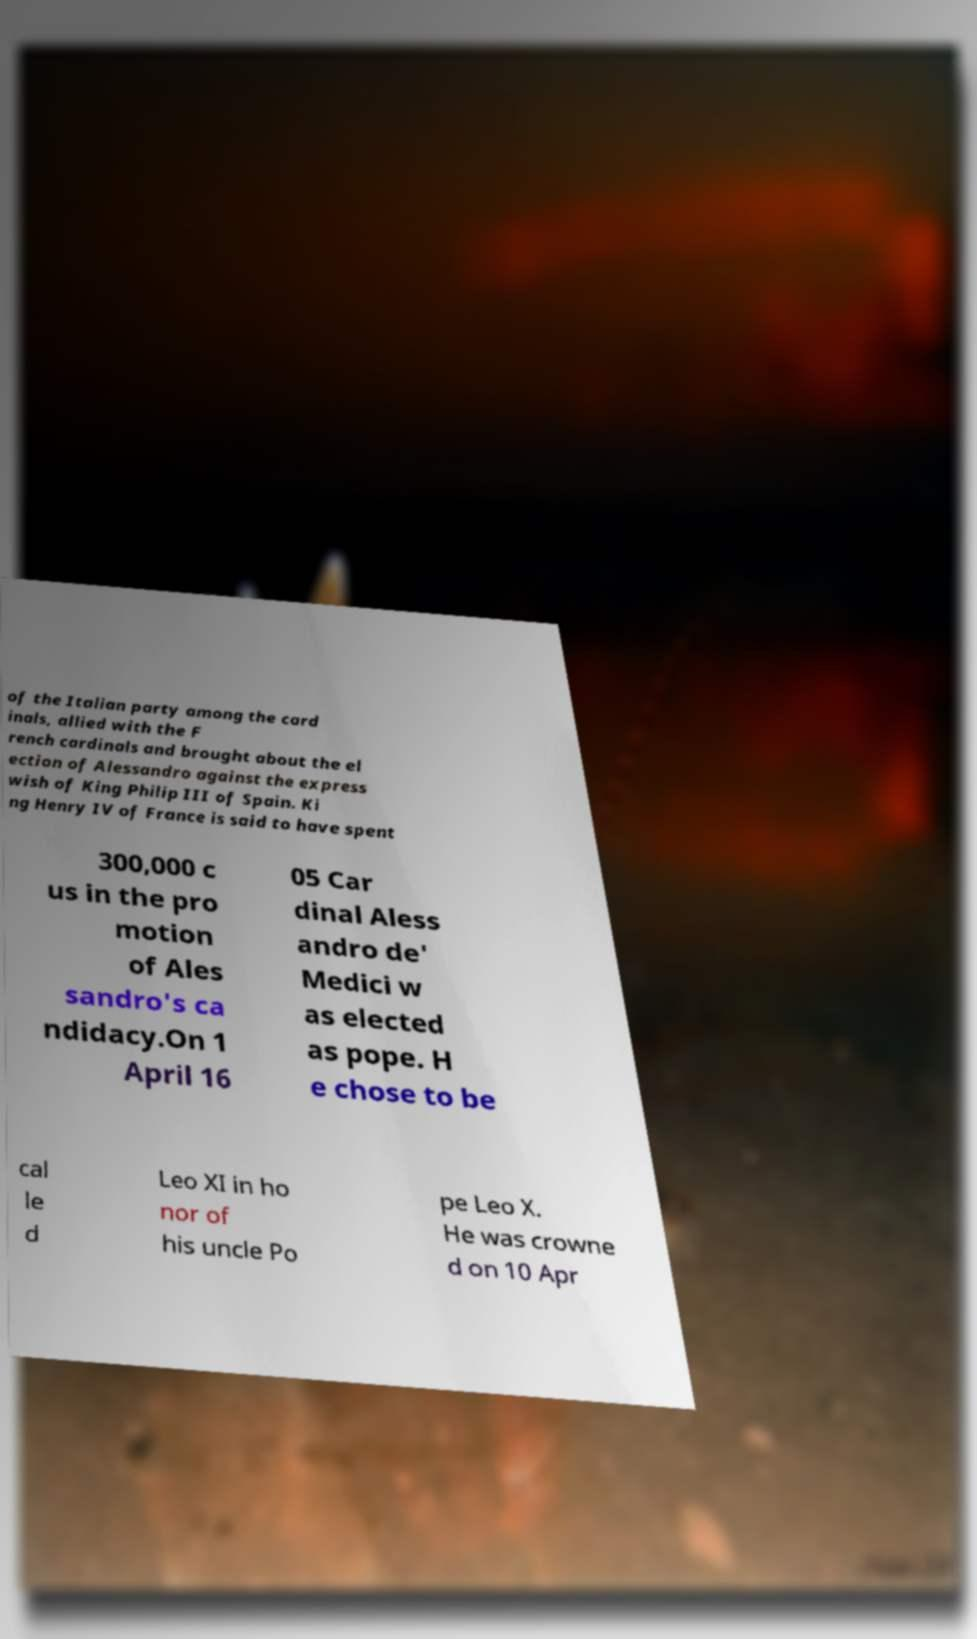Can you read and provide the text displayed in the image?This photo seems to have some interesting text. Can you extract and type it out for me? of the Italian party among the card inals, allied with the F rench cardinals and brought about the el ection of Alessandro against the express wish of King Philip III of Spain. Ki ng Henry IV of France is said to have spent 300,000 c us in the pro motion of Ales sandro's ca ndidacy.On 1 April 16 05 Car dinal Aless andro de' Medici w as elected as pope. H e chose to be cal le d Leo XI in ho nor of his uncle Po pe Leo X. He was crowne d on 10 Apr 